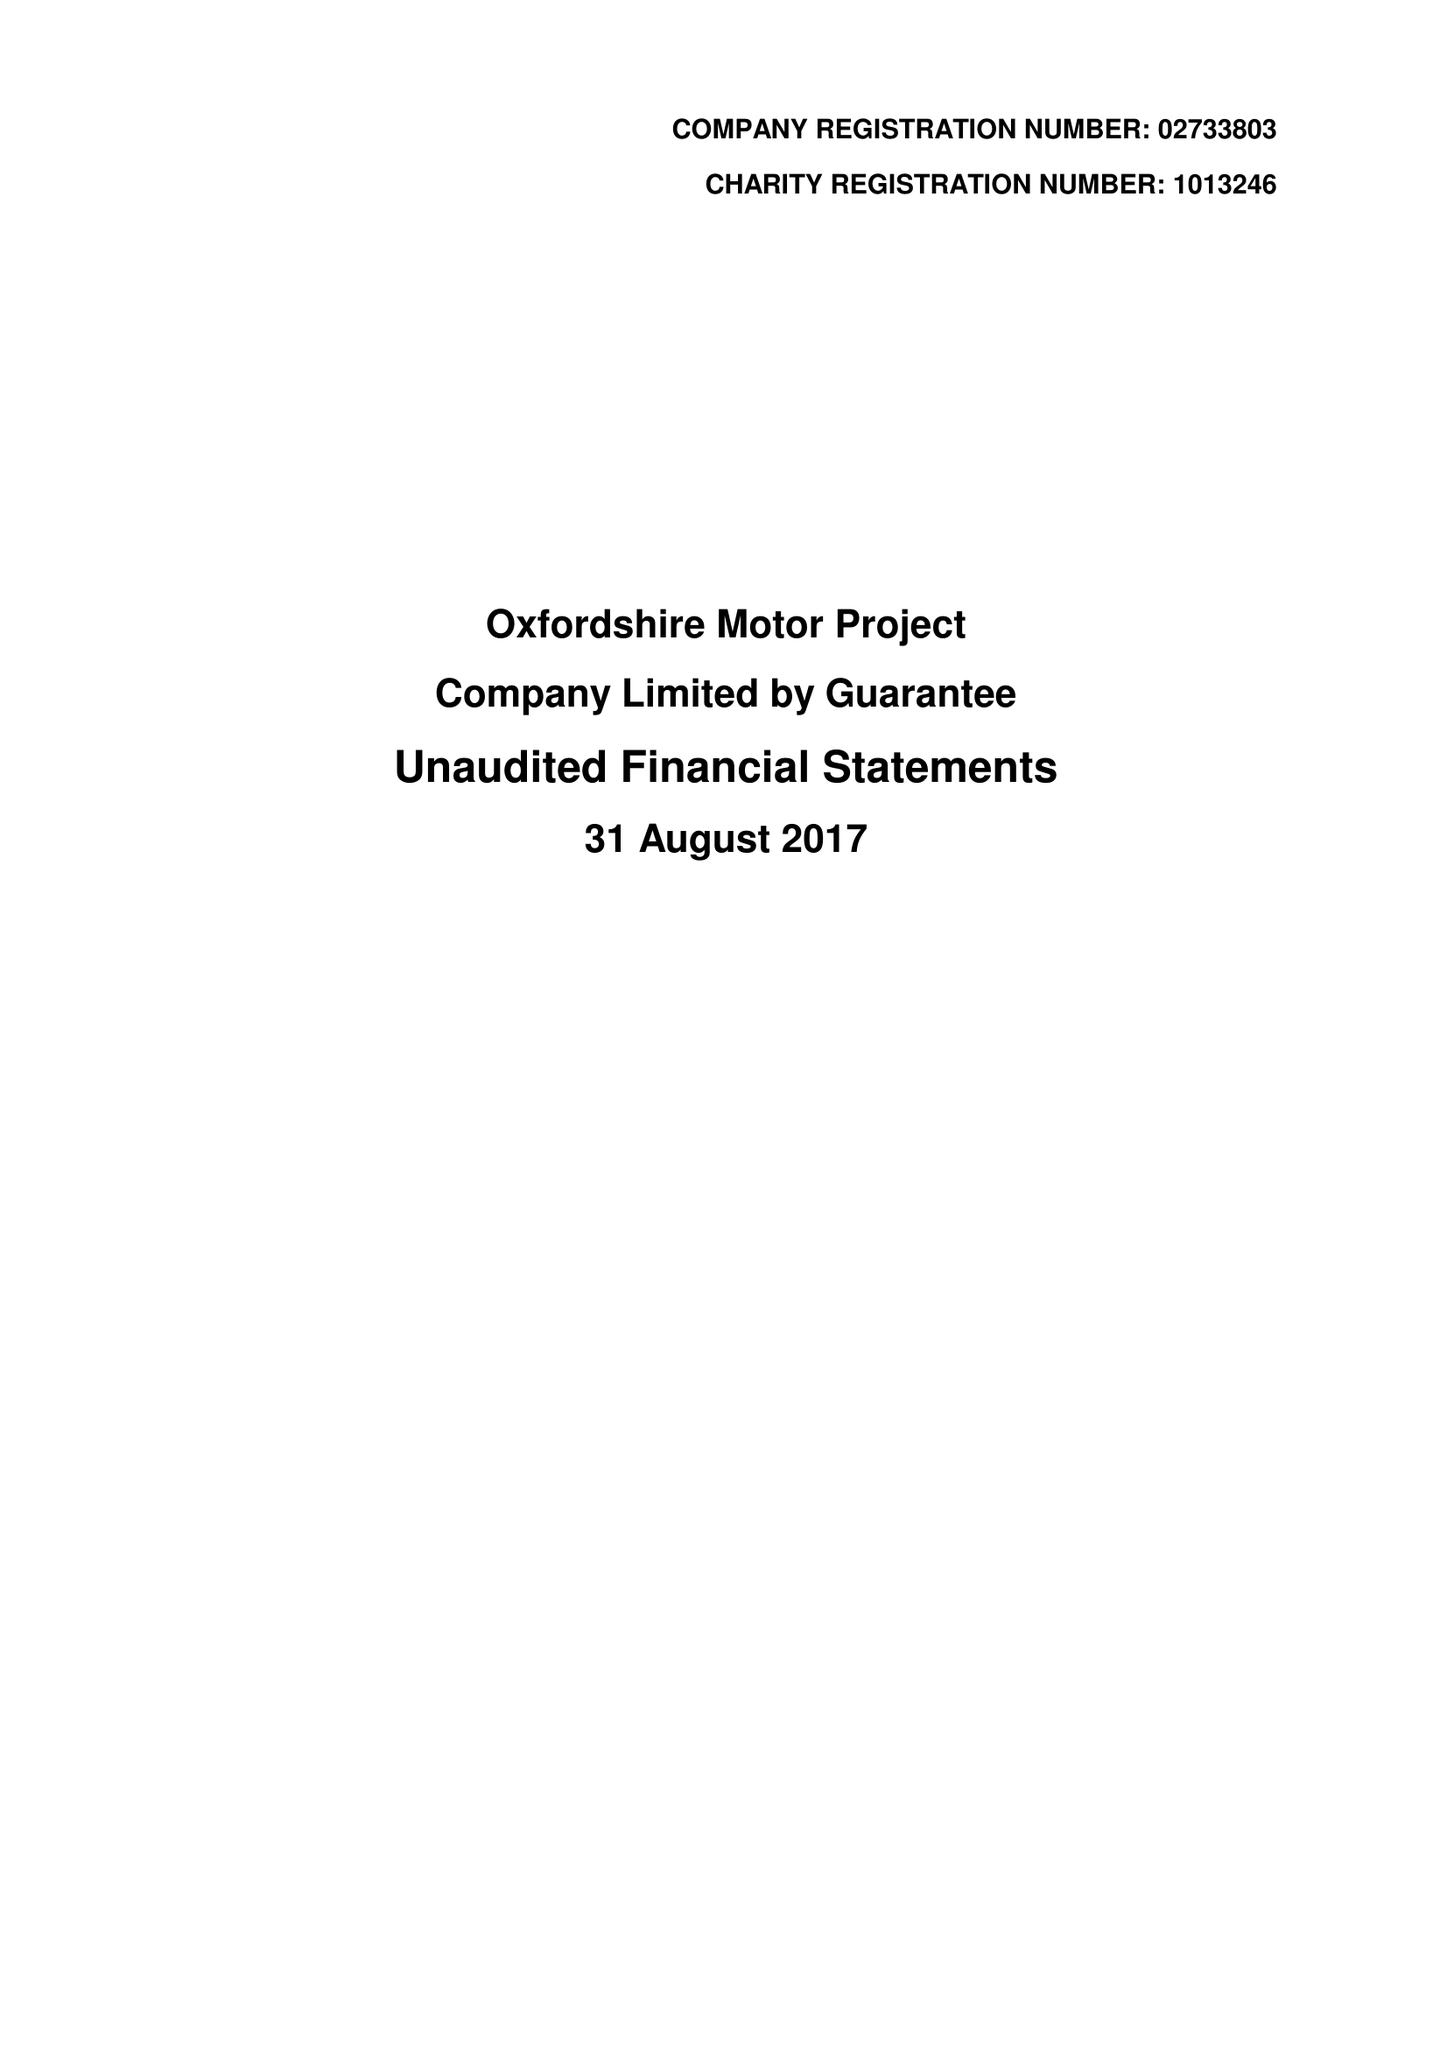What is the value for the address__postcode?
Answer the question using a single word or phrase. OX2 8JR 